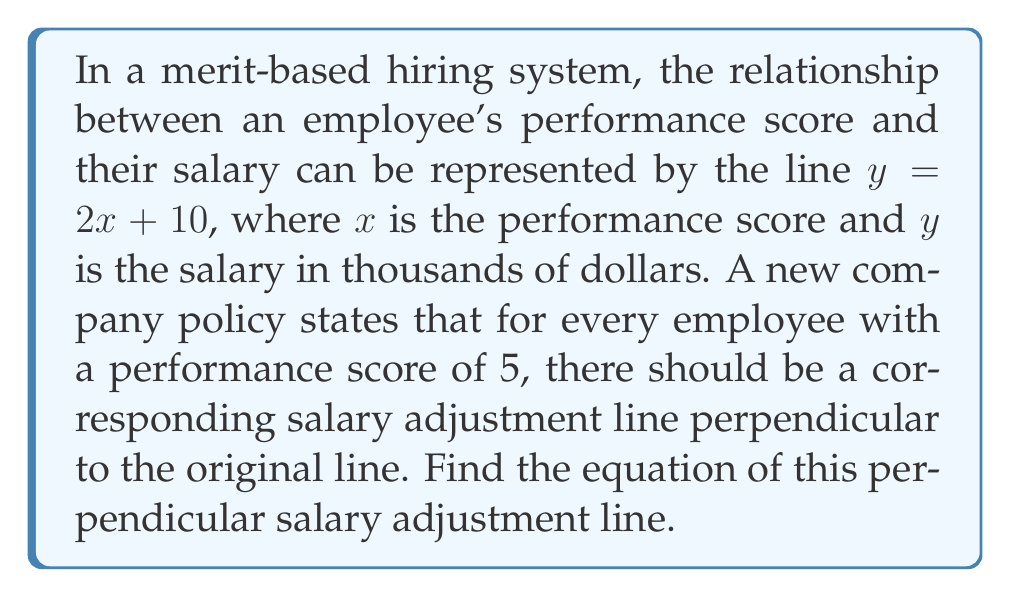Help me with this question. To find the equation of a line perpendicular to a given line and passing through a specific point, we need to follow these steps:

1. Identify the slope of the given line:
   The original line has the equation $y = 2x + 10$, so its slope is $m_1 = 2$.

2. Calculate the slope of the perpendicular line:
   For perpendicular lines, the product of their slopes is -1. So, if $m_1 \cdot m_2 = -1$, then:
   $m_2 = -\frac{1}{m_1} = -\frac{1}{2}$

3. Determine the point through which the perpendicular line passes:
   We're told the performance score is 5, so we need to find the corresponding y-value on the original line:
   $y = 2(5) + 10 = 20$
   The point is (5, 20).

4. Use the point-slope form of a line to write the equation:
   $y - y_1 = m(x - x_1)$
   $y - 20 = -\frac{1}{2}(x - 5)$

5. Simplify to slope-intercept form:
   $y - 20 = -\frac{1}{2}x + \frac{5}{2}$
   $y = -\frac{1}{2}x + \frac{5}{2} + 20$
   $y = -\frac{1}{2}x + \frac{45}{2}$

Therefore, the equation of the perpendicular salary adjustment line is $y = -\frac{1}{2}x + \frac{45}{2}$.
Answer: $y = -\frac{1}{2}x + \frac{45}{2}$ 